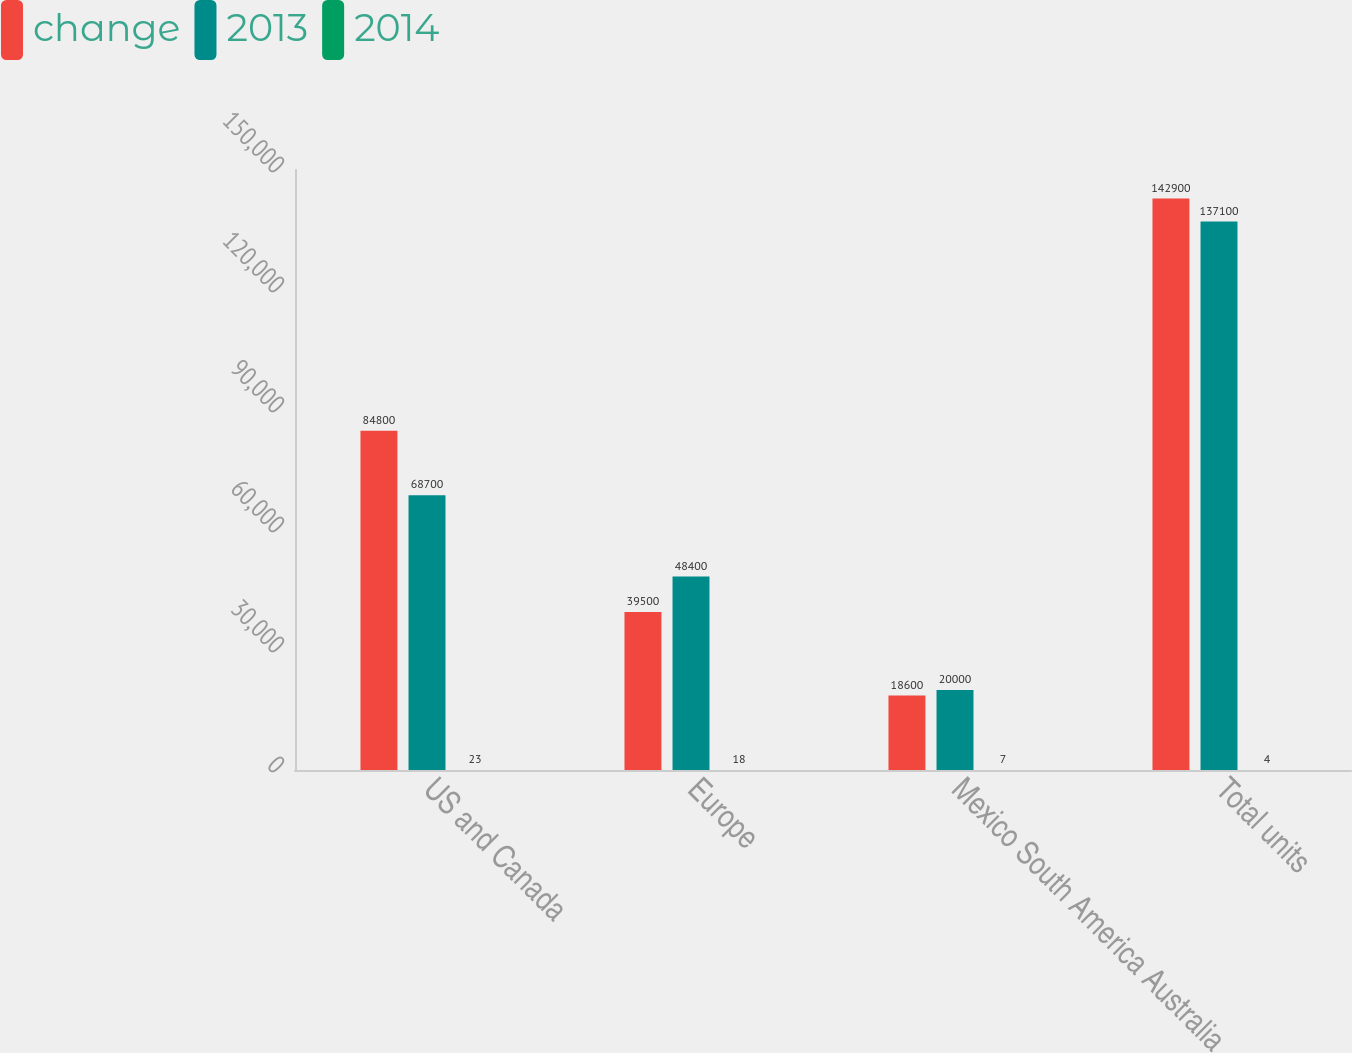Convert chart to OTSL. <chart><loc_0><loc_0><loc_500><loc_500><stacked_bar_chart><ecel><fcel>US and Canada<fcel>Europe<fcel>Mexico South America Australia<fcel>Total units<nl><fcel>change<fcel>84800<fcel>39500<fcel>18600<fcel>142900<nl><fcel>2013<fcel>68700<fcel>48400<fcel>20000<fcel>137100<nl><fcel>2014<fcel>23<fcel>18<fcel>7<fcel>4<nl></chart> 